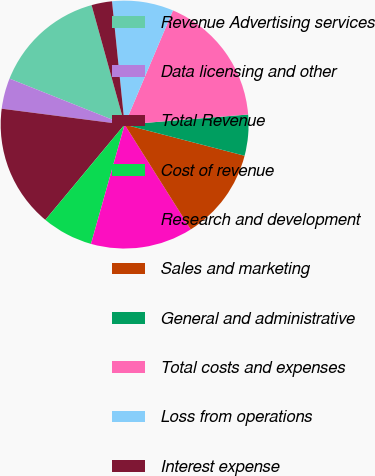Convert chart. <chart><loc_0><loc_0><loc_500><loc_500><pie_chart><fcel>Revenue Advertising services<fcel>Data licensing and other<fcel>Total Revenue<fcel>Cost of revenue<fcel>Research and development<fcel>Sales and marketing<fcel>General and administrative<fcel>Total costs and expenses<fcel>Loss from operations<fcel>Interest expense<nl><fcel>14.66%<fcel>4.0%<fcel>16.0%<fcel>6.67%<fcel>13.33%<fcel>12.0%<fcel>5.34%<fcel>17.33%<fcel>8.0%<fcel>2.67%<nl></chart> 